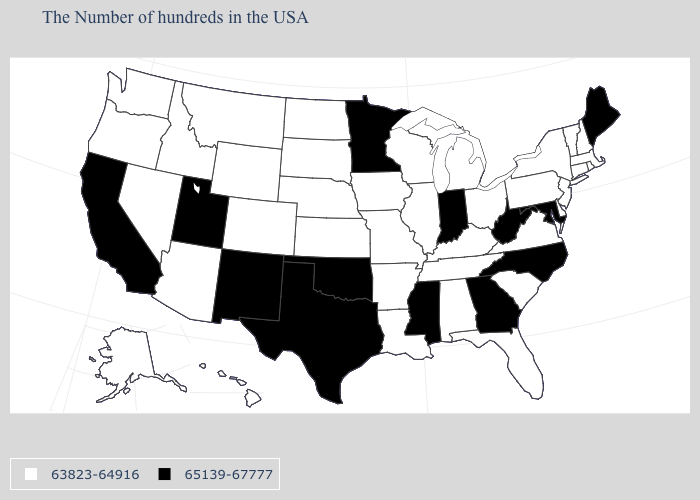Among the states that border Indiana , which have the lowest value?
Short answer required. Ohio, Michigan, Kentucky, Illinois. Among the states that border Arizona , which have the lowest value?
Short answer required. Colorado, Nevada. Name the states that have a value in the range 63823-64916?
Short answer required. Massachusetts, Rhode Island, New Hampshire, Vermont, Connecticut, New York, New Jersey, Delaware, Pennsylvania, Virginia, South Carolina, Ohio, Florida, Michigan, Kentucky, Alabama, Tennessee, Wisconsin, Illinois, Louisiana, Missouri, Arkansas, Iowa, Kansas, Nebraska, South Dakota, North Dakota, Wyoming, Colorado, Montana, Arizona, Idaho, Nevada, Washington, Oregon, Alaska, Hawaii. What is the lowest value in the USA?
Be succinct. 63823-64916. How many symbols are there in the legend?
Keep it brief. 2. Does the first symbol in the legend represent the smallest category?
Short answer required. Yes. Which states have the lowest value in the USA?
Answer briefly. Massachusetts, Rhode Island, New Hampshire, Vermont, Connecticut, New York, New Jersey, Delaware, Pennsylvania, Virginia, South Carolina, Ohio, Florida, Michigan, Kentucky, Alabama, Tennessee, Wisconsin, Illinois, Louisiana, Missouri, Arkansas, Iowa, Kansas, Nebraska, South Dakota, North Dakota, Wyoming, Colorado, Montana, Arizona, Idaho, Nevada, Washington, Oregon, Alaska, Hawaii. Name the states that have a value in the range 65139-67777?
Write a very short answer. Maine, Maryland, North Carolina, West Virginia, Georgia, Indiana, Mississippi, Minnesota, Oklahoma, Texas, New Mexico, Utah, California. Does Hawaii have a lower value than Indiana?
Concise answer only. Yes. What is the highest value in the South ?
Concise answer only. 65139-67777. Which states have the lowest value in the MidWest?
Answer briefly. Ohio, Michigan, Wisconsin, Illinois, Missouri, Iowa, Kansas, Nebraska, South Dakota, North Dakota. What is the value of Michigan?
Write a very short answer. 63823-64916. What is the highest value in the USA?
Give a very brief answer. 65139-67777. What is the value of Alabama?
Quick response, please. 63823-64916. What is the lowest value in the USA?
Quick response, please. 63823-64916. 